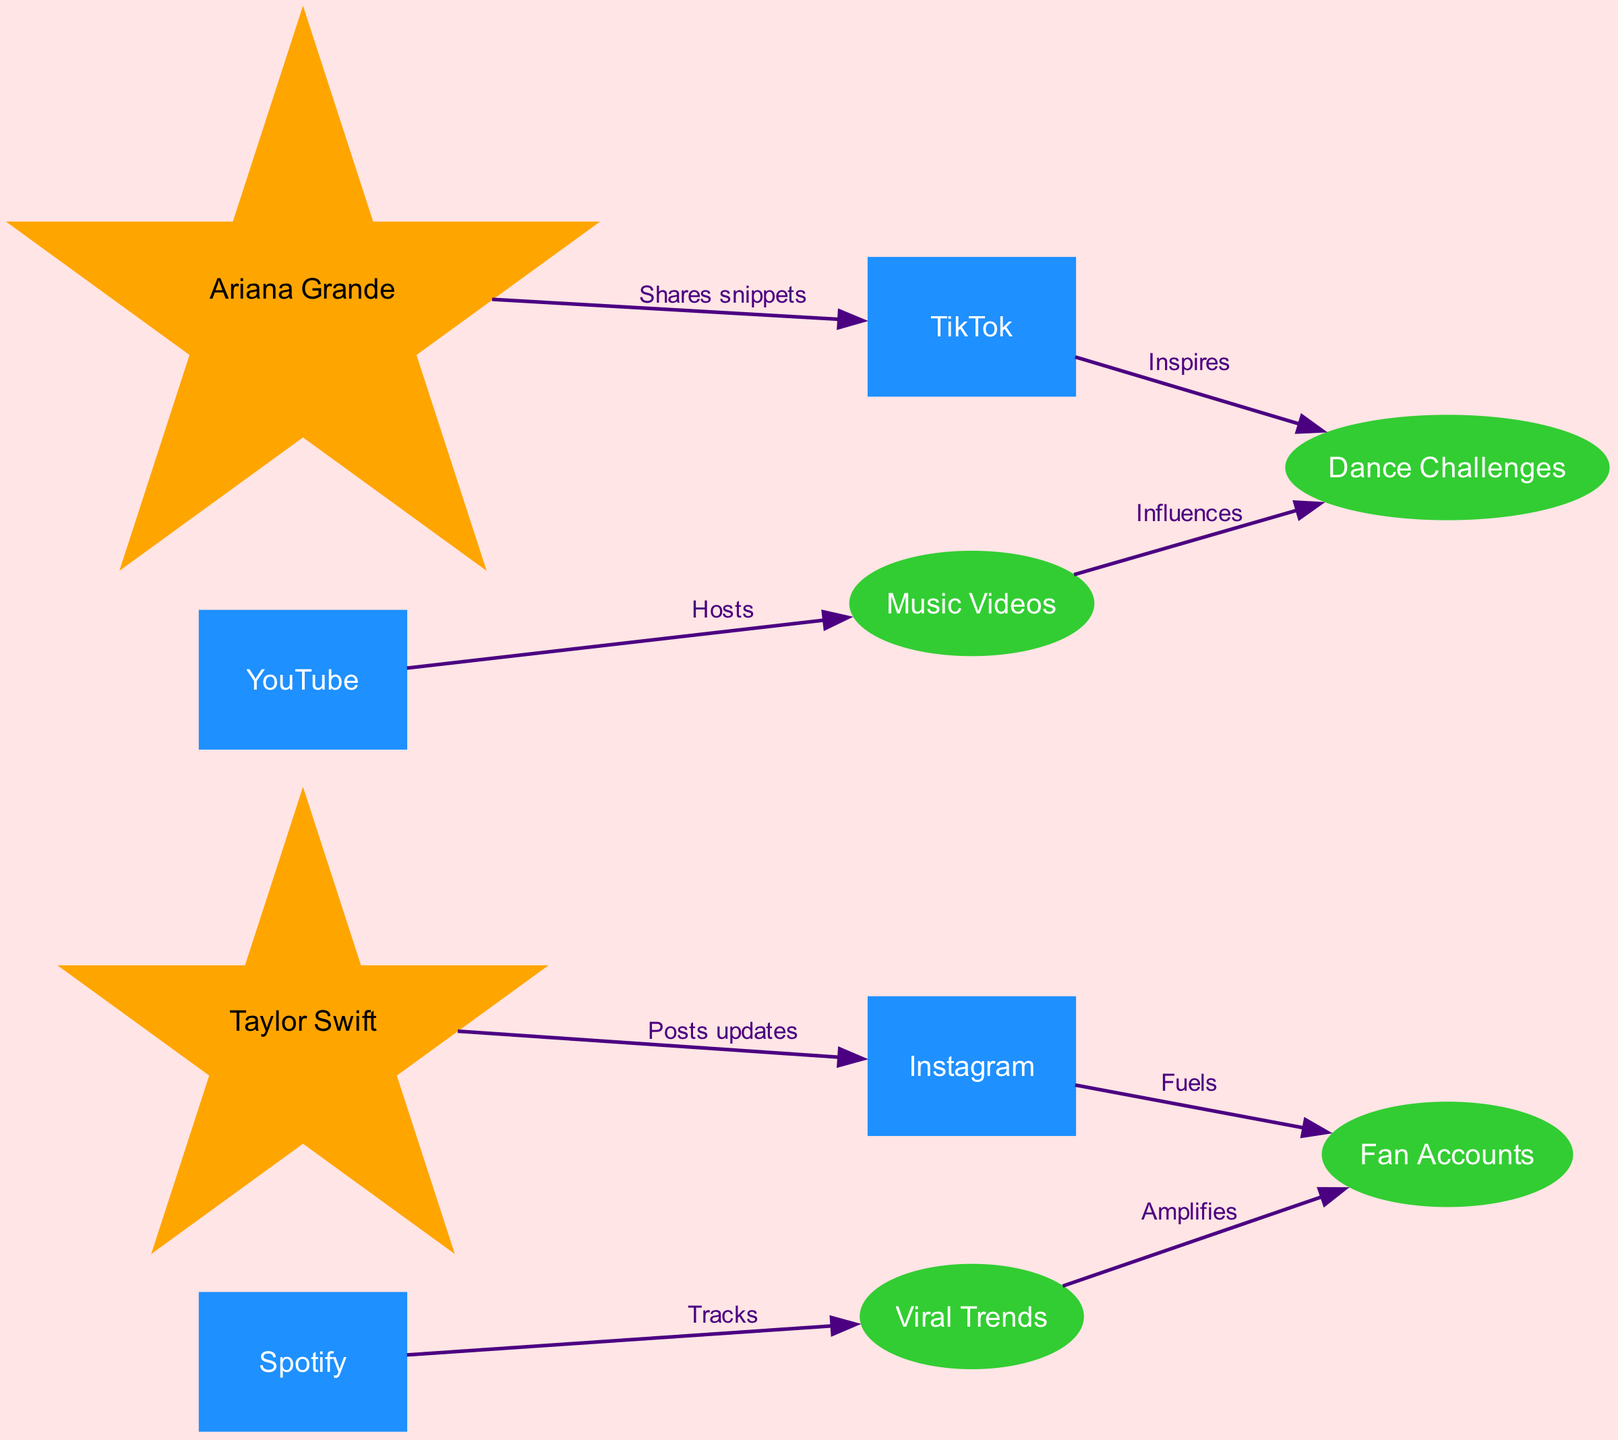What is the total number of nodes in the diagram? Counting the nodes listed in the data provided, there are a total of 9 unique nodes: Taylor Swift, Ariana Grande, TikTok, Instagram, YouTube, Spotify, Fan Accounts, Music Videos, and Dance Challenges.
Answer: 9 Which social media platform does Taylor Swift influence with her posts? The directed edge from Taylor Swift to Instagram shows that Taylor influences Instagram through her posts.
Answer: Instagram What type of content inspires Dance Challenges? The diagram indicates that TikTok inspires Dance Challenges, as shown by the directed edge from TikTok to Dance Challenges.
Answer: TikTok How many edges are present in the diagram? By examining the edges listed in the data, there are a total of 8 unique edges connecting the nodes.
Answer: 8 What does Spotify track in the influence flow? The edge from Spotify to Viral Trends indicates that Spotify tracks Viral Trends.
Answer: Viral Trends Which idol shares snippets on TikTok? The directed edge from Ariana Grande to TikTok shows that Ariana Grande shares snippets on TikTok.
Answer: Ariana Grande Which factors amplify the influence of Fan Accounts? The diagram illustrates that Viral Trends amplify Fan Accounts, as shown by the directed edge from Viral Trends to Fan Accounts.
Answer: Viral Trends What influences Dance Challenges apart from TikTok? The diagram shows that Music Videos also influence Dance Challenges, indicated by the edge from Music Videos to Dance Challenges.
Answer: Music Videos Which platform hosts Music Videos? The directed edge from YouTube to Music Videos indicates that YouTube hosts Music Videos.
Answer: YouTube 